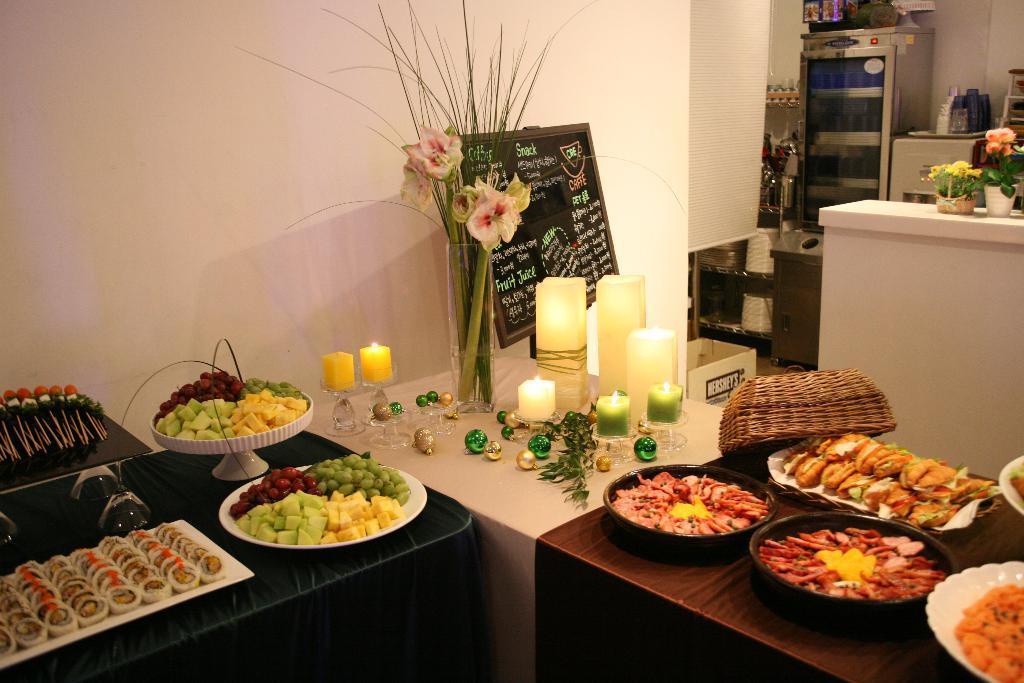Please provide a concise description of this image. There was so much food served in plates on a table and a candle in the middle of it with a flower-vase and a fridge at one corner of the room. 